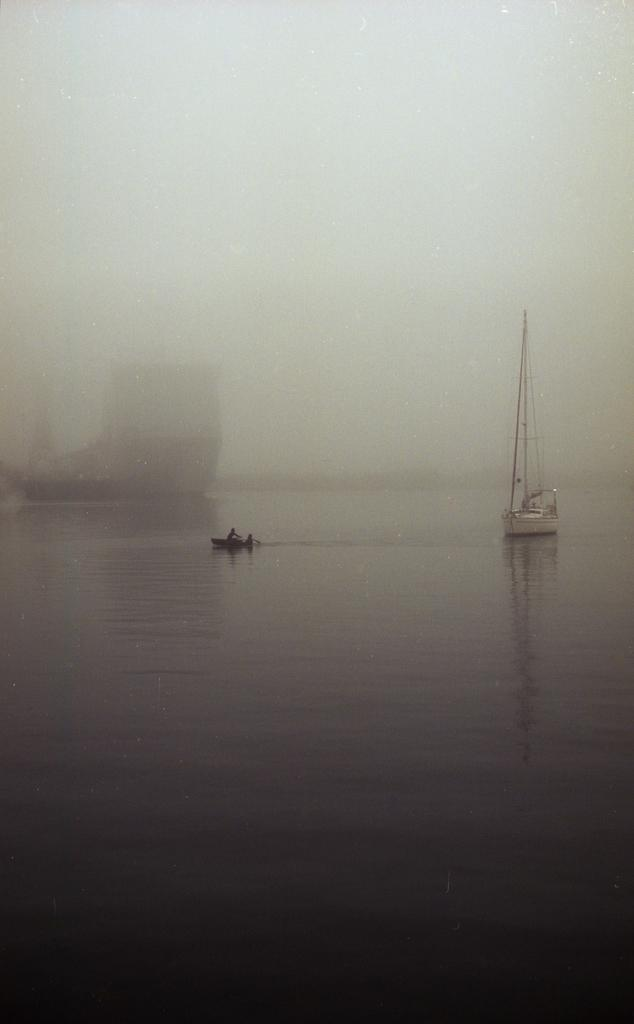What is in the water in the image? There are boats in the water in the image. What atmospheric condition can be observed in the image? There is fog visible in the image. Can you describe the people in the image? There are people seated on a boat in the image. What type of debt is being discussed by the people on the boat in the image? There is no indication of a debt discussion in the image; it features boats, fog, and people seated on a boat. What subject is the person teaching to the others on the boat in the image? There is no person teaching a subject in the image; it only shows boats, fog, and people seated on a boat. 